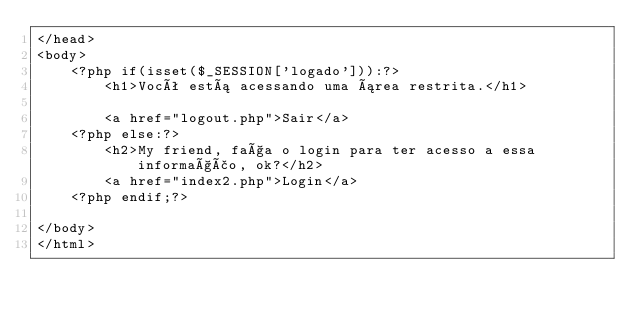<code> <loc_0><loc_0><loc_500><loc_500><_PHP_></head>
<body>
    <?php if(isset($_SESSION['logado'])):?>
        <h1>Você está acessando uma área restrita.</h1>

        <a href="logout.php">Sair</a>
    <?php else:?>
        <h2>My friend, faça o login para ter acesso a essa informação, ok?</h2>
        <a href="index2.php">Login</a>
    <?php endif;?>

</body>
</html></code> 